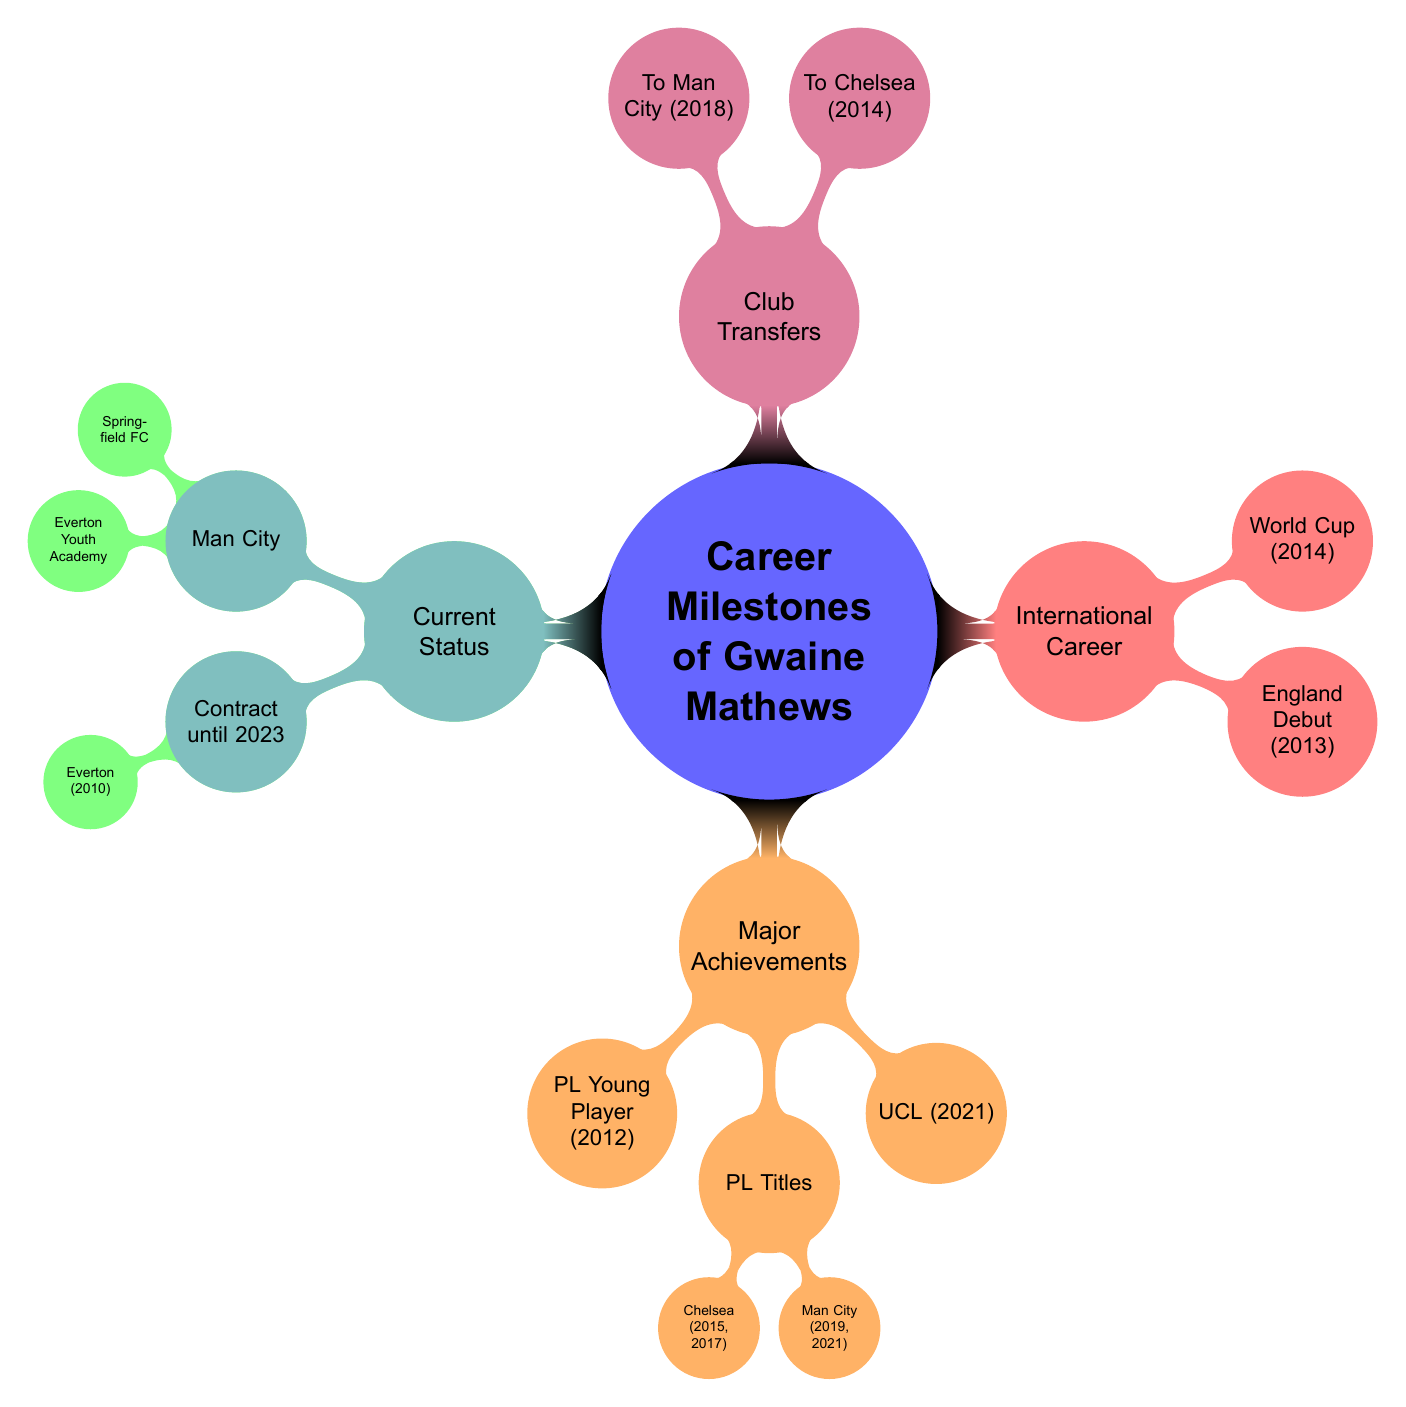What were Gwaine Mathews' youth clubs? The diagram shows two nodes under "Youth Clubs": Springfield FC and Everton Youth Academy. Both represent the early clubs he was associated with before starting his professional career.
Answer: Springfield FC, Everton Youth Academy In which year did Gwaine Mathews receive his first professional contract? Under the "First Professional Contract" node, it states that he signed with Everton in 2010, indicating this as the year he turned professional.
Answer: 2010 What was Gwaine Mathews' major achievement in 2012? The diagram highlights that he received the title of "Premier League Young Player of the Year" in 2012 under "First Major Achievement." This is a key recognition early in his career.
Answer: Premier League Young Player of the Year Which tournament did Gwaine Mathews participate in during 2014? The diagram indicates that he made his international debut with the England National Team and participated in the FIFA World Cup, both noted under "International Career." The year 2014 is connected to the tournament specifically.
Answer: FIFA World Cup What were the transfer fees when Gwaine Mathews moved to Chelsea and Manchester City? The diagram specifies that he transferred to Chelsea for £40 million in 2014 and to Manchester City for £60 million in 2018, illustrating significant financial transactions in his career.
Answer: £40 million, £60 million How many Premier League titles did Gwaine Mathews win with Chelsea? The diagram lists two years (2015 and 2017) under "Premier League Titles" for Chelsea, indicating the number of titles won during his time there.
Answer: 2 In what year did Gwaine Mathews debut for the England National Team? The diagram shows "England Debut" under "International Career," specifying that it occurred in the year 2013, making it the first key international milestone.
Answer: 2013 With which club is Gwaine Mathews currently contracted? The diagram clearly states that his "Current Club" is Manchester City, pinpointing his professional affiliation at this moment in time.
Answer: Manchester City What are the years associated with Gwaine Mathews' Premier League titles won with Manchester City? The diagram lists the years 2019 and 2021 under "Premier League Titles" for Manchester City, indicating when he achieved these successes.
Answer: 2019, 2021 